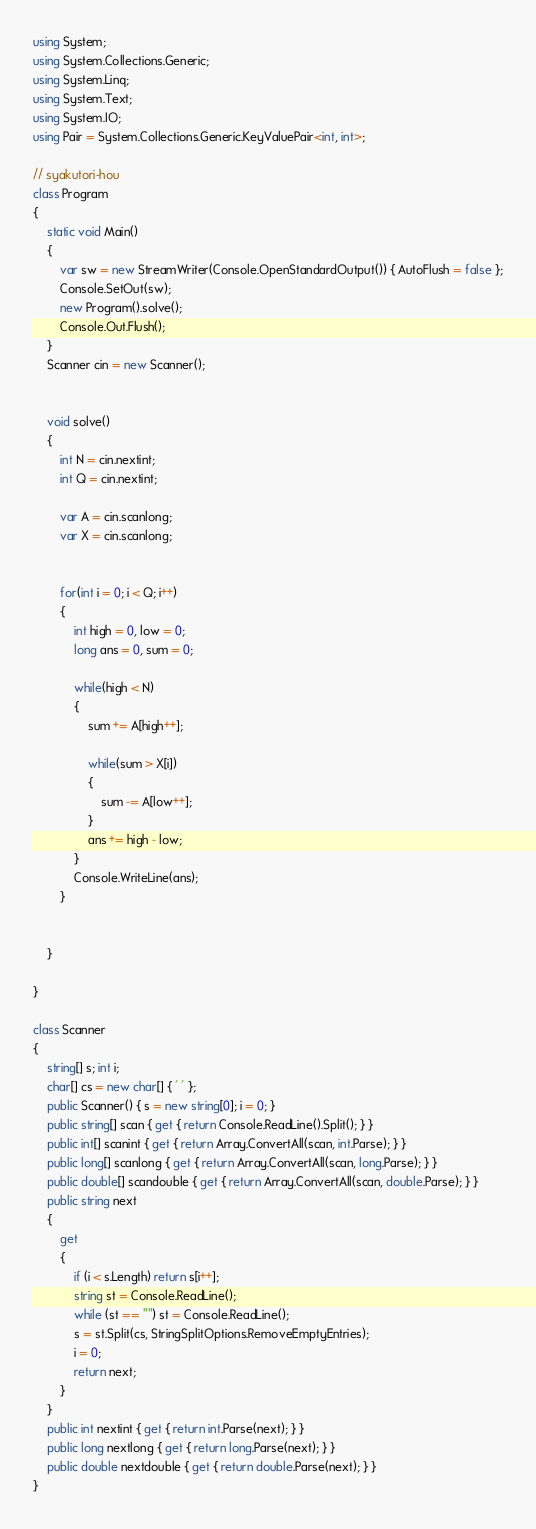<code> <loc_0><loc_0><loc_500><loc_500><_C#_>using System;
using System.Collections.Generic;
using System.Linq;
using System.Text;
using System.IO;
using Pair = System.Collections.Generic.KeyValuePair<int, int>;
  
// syakutori-hou
class Program
{
    static void Main()
    {
        var sw = new StreamWriter(Console.OpenStandardOutput()) { AutoFlush = false };
        Console.SetOut(sw);
        new Program().solve();
        Console.Out.Flush();
    }
    Scanner cin = new Scanner();
  
  
    void solve()
    {
        int N = cin.nextint;
        int Q = cin.nextint;
         
        var A = cin.scanlong;
        var X = cin.scanlong;
         
         
        for(int i = 0; i < Q; i++)
        {
            int high = 0, low = 0; 
            long ans = 0, sum = 0;
             
            while(high < N)
            {
                sum += A[high++];
                 
                while(sum > X[i])
                {
                    sum -= A[low++];
                }
                ans += high - low;
            }
            Console.WriteLine(ans);
        }
         
         
    }
  
}
  
class Scanner
{
    string[] s; int i;
    char[] cs = new char[] { ' ' };
    public Scanner() { s = new string[0]; i = 0; }
    public string[] scan { get { return Console.ReadLine().Split(); } }
    public int[] scanint { get { return Array.ConvertAll(scan, int.Parse); } }
    public long[] scanlong { get { return Array.ConvertAll(scan, long.Parse); } }
    public double[] scandouble { get { return Array.ConvertAll(scan, double.Parse); } }
    public string next
    {
        get
        {
            if (i < s.Length) return s[i++];
            string st = Console.ReadLine();
            while (st == "") st = Console.ReadLine();
            s = st.Split(cs, StringSplitOptions.RemoveEmptyEntries);
            i = 0;
            return next;
        }
    }
    public int nextint { get { return int.Parse(next); } }
    public long nextlong { get { return long.Parse(next); } }
    public double nextdouble { get { return double.Parse(next); } }
}</code> 